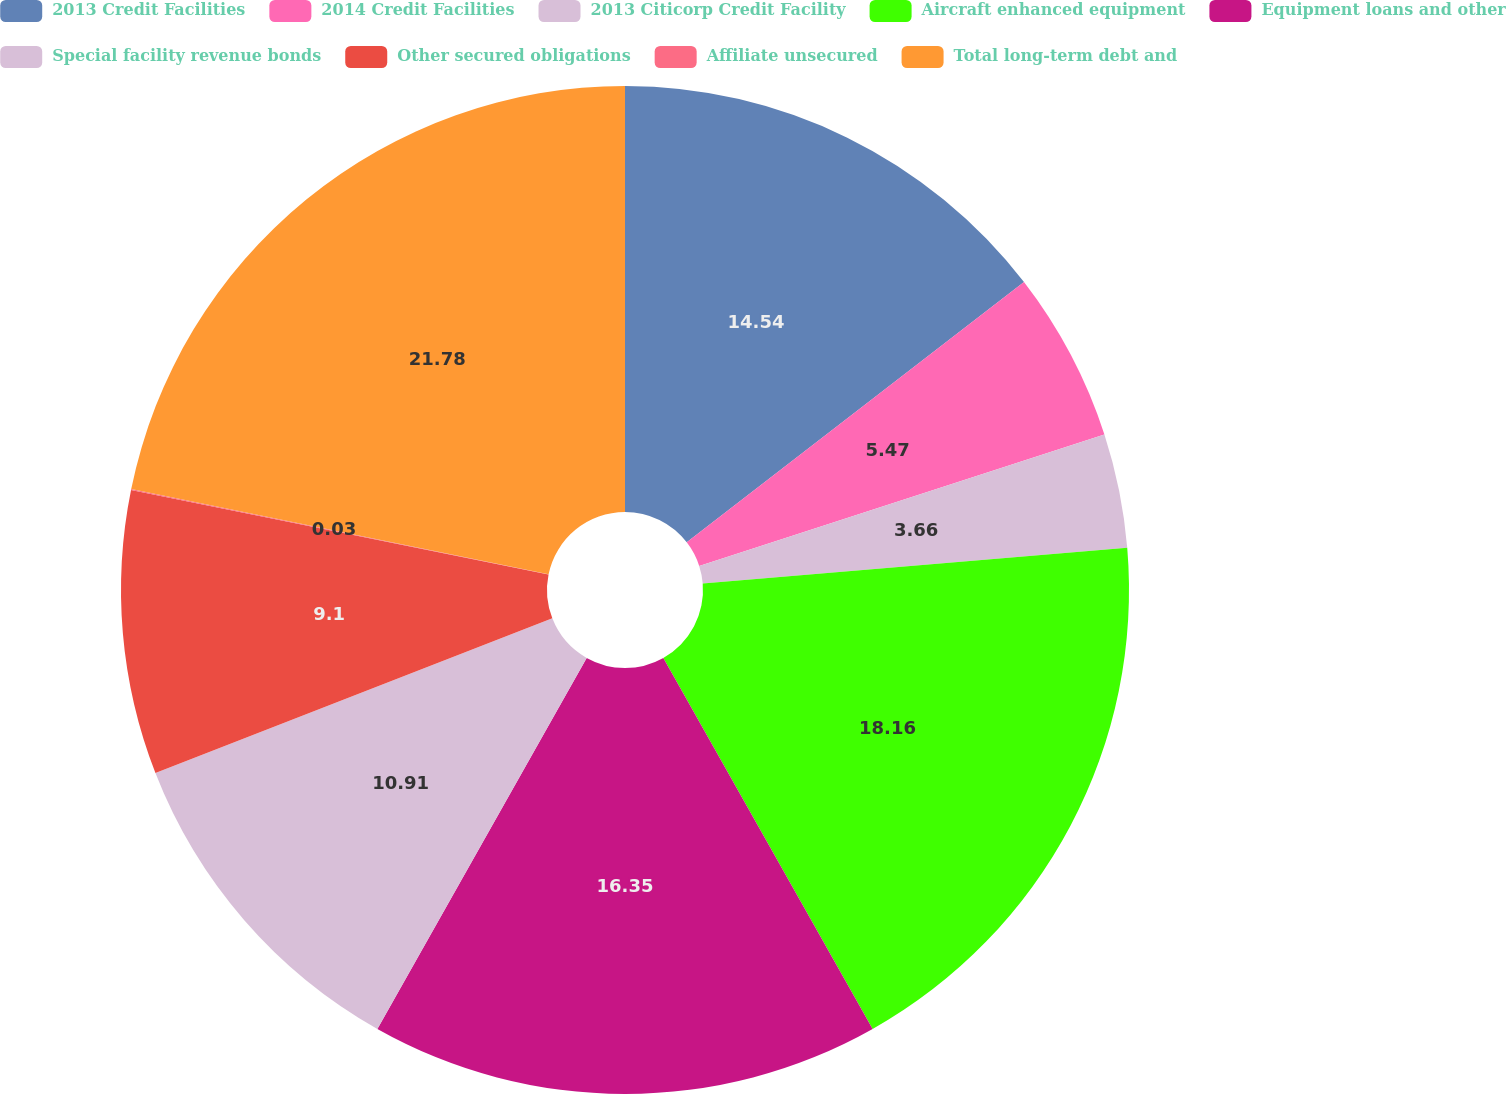Convert chart. <chart><loc_0><loc_0><loc_500><loc_500><pie_chart><fcel>2013 Credit Facilities<fcel>2014 Credit Facilities<fcel>2013 Citicorp Credit Facility<fcel>Aircraft enhanced equipment<fcel>Equipment loans and other<fcel>Special facility revenue bonds<fcel>Other secured obligations<fcel>Affiliate unsecured<fcel>Total long-term debt and<nl><fcel>14.54%<fcel>5.47%<fcel>3.66%<fcel>18.16%<fcel>16.35%<fcel>10.91%<fcel>9.1%<fcel>0.03%<fcel>21.79%<nl></chart> 